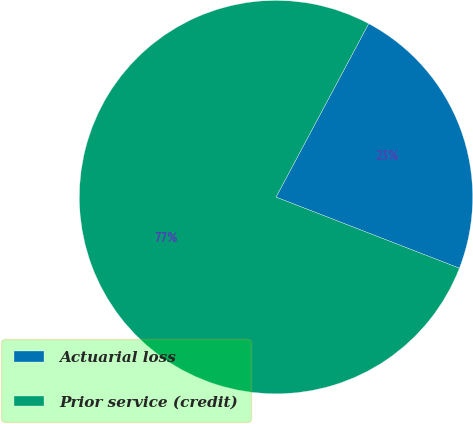Convert chart to OTSL. <chart><loc_0><loc_0><loc_500><loc_500><pie_chart><fcel>Actuarial loss<fcel>Prior service (credit)<nl><fcel>23.08%<fcel>76.92%<nl></chart> 